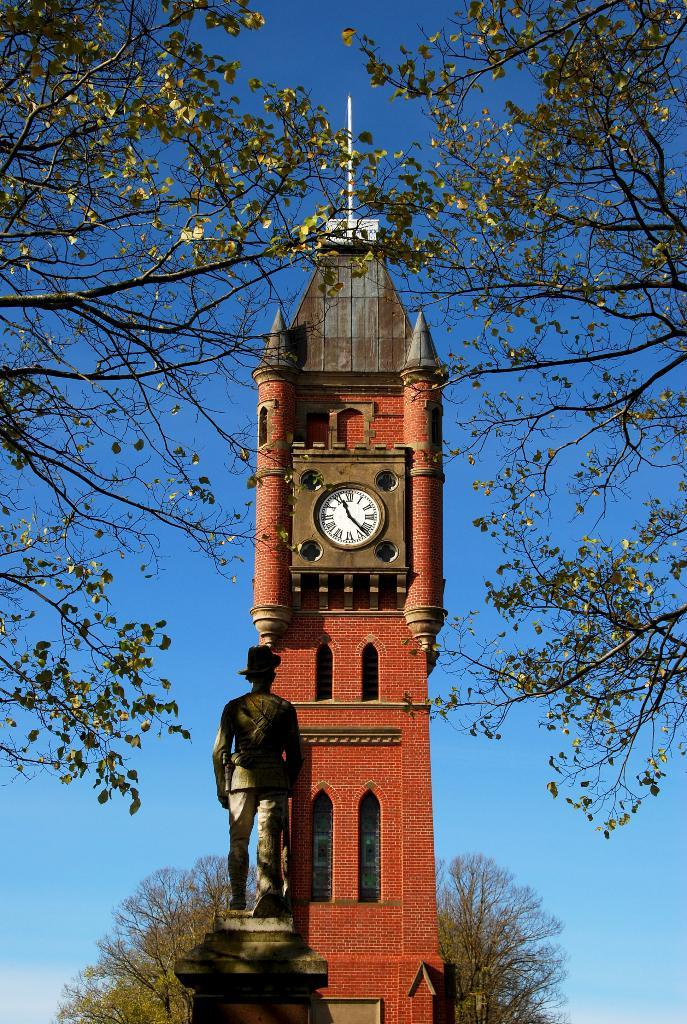Provide a one-sentence caption for the provided image. A statue is in front of a brick clock tower showing the time 11:26. 